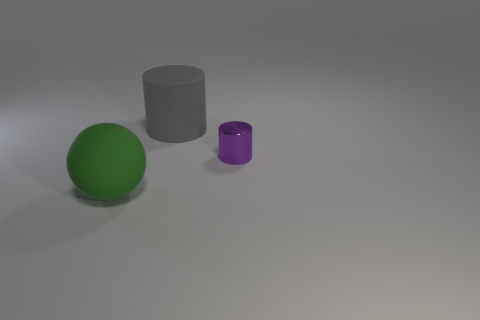Are the colors of the objects indicative of anything specific? The colors in the image don't necessarily indicate anything specific—it could be an artistic choice or a random selection. However, the green sphere and the purple cylinder stand out against the neutral background, possibly signifying that these objects are meant to be the focus of the image. The contrast between the colors could suggest a theme of diversity or complementarity. 